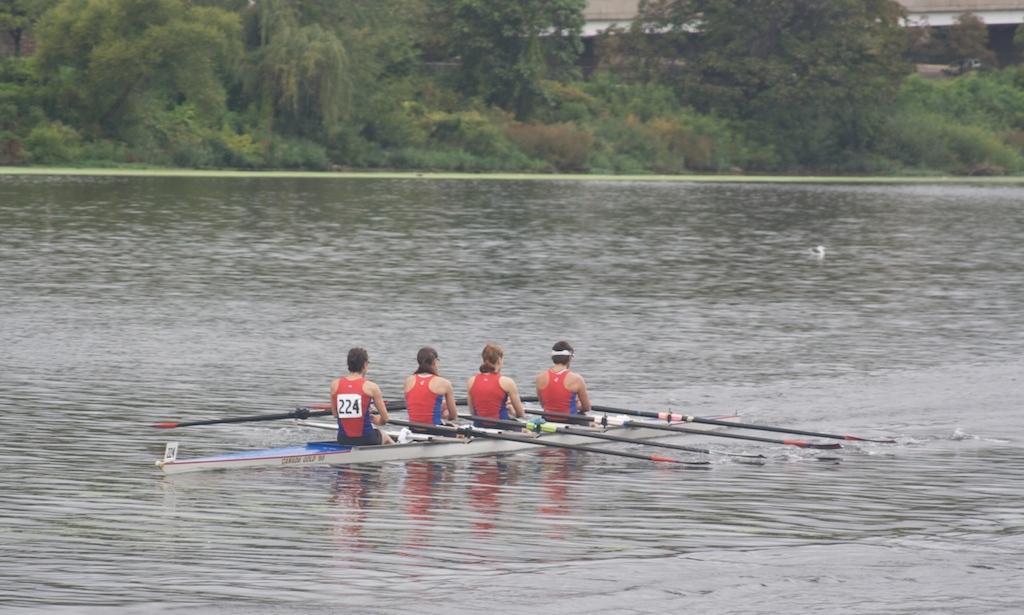In one or two sentences, can you explain what this image depicts? In this image in the center there are persons sitting on a surf boat and rowing a surf boat on the water. In the background there are trees. 